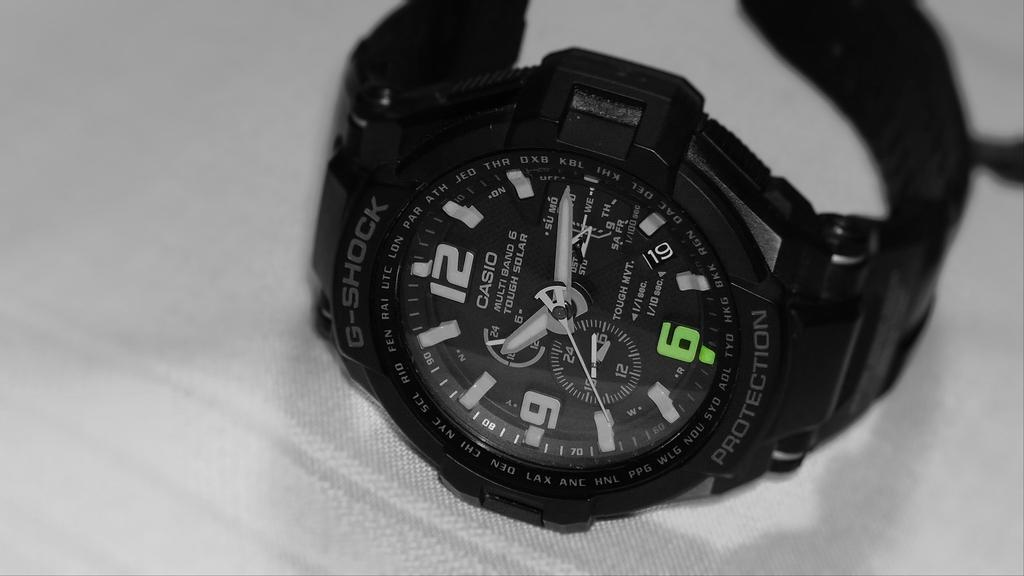<image>
Relay a brief, clear account of the picture shown. Black and white picture of a Casio stop watch. 